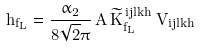Convert formula to latex. <formula><loc_0><loc_0><loc_500><loc_500>\tilde { h } _ { f _ { L } } = \frac { \alpha _ { 2 } } { 8 \sqrt { 2 } \pi } \, A \, { \widetilde { K } } _ { f _ { L } } ^ { \, i j l k h } \, V _ { i j l k h }</formula> 